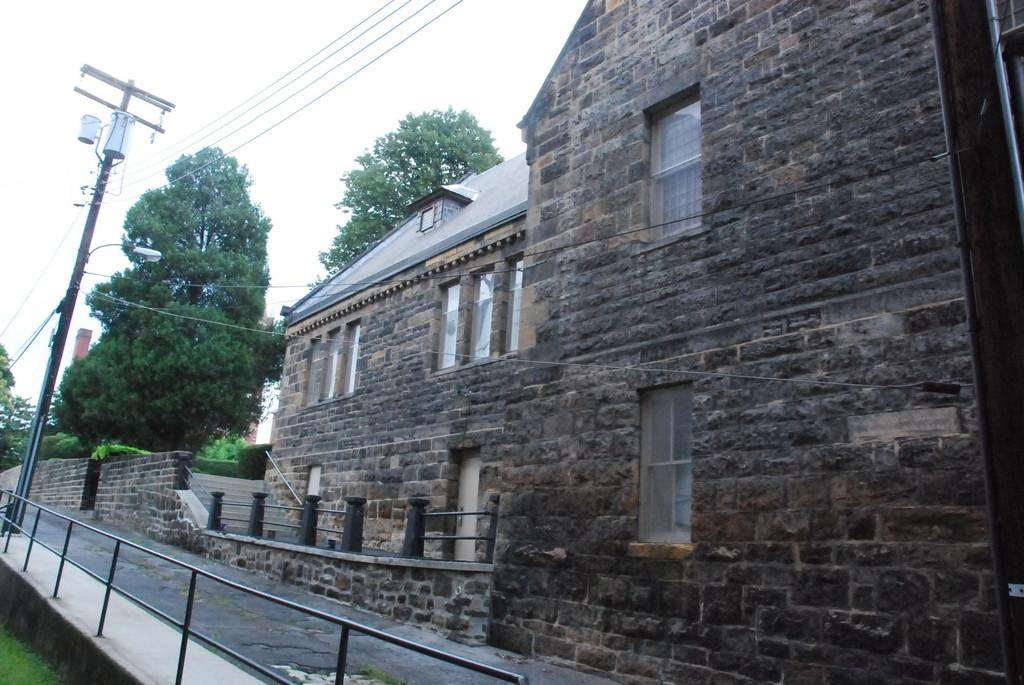What type of structures can be seen in the image? There are buildings in the image. What other natural elements are present in the image? There are trees in the image. What is the path used for in the image? The path is in front of the building, likely for people to walk on. What is the purpose of the railing in front of the building? The railing is likely for safety or to prevent people from getting too close to the building or the path. What is attached to the utility pole in front of the building? There are cables attached to the utility pole in front of the building. What can be seen in the background of the image? The sky is visible in the background of the image. What type of pie is being served at the heart-shaped table in the image? There is no pie or heart-shaped table present in the image. How does the building expand in the image? The building does not expand in the image; it is a static structure. 